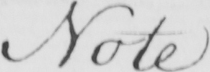Can you tell me what this handwritten text says? Note 